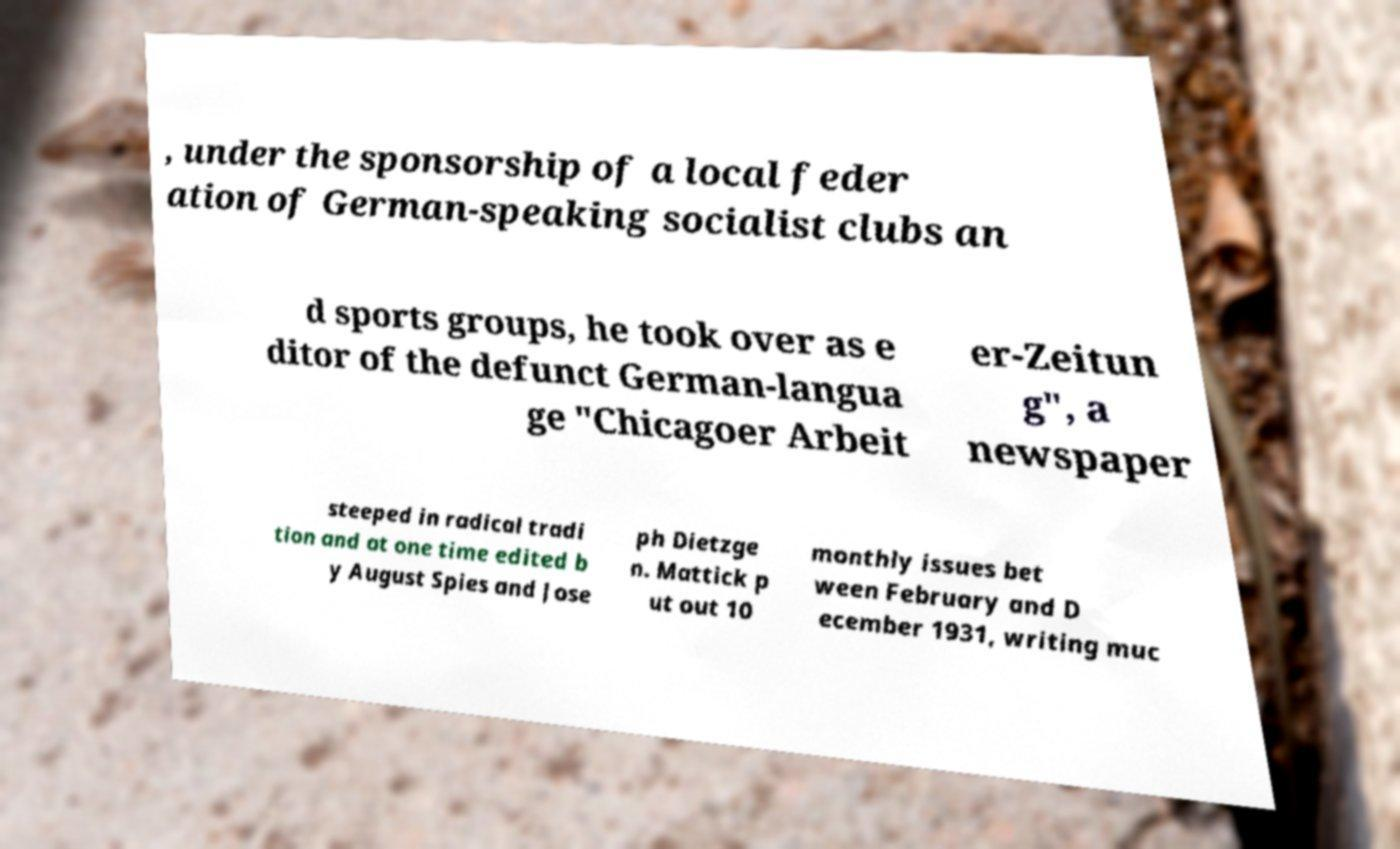Please identify and transcribe the text found in this image. , under the sponsorship of a local feder ation of German-speaking socialist clubs an d sports groups, he took over as e ditor of the defunct German-langua ge "Chicagoer Arbeit er-Zeitun g", a newspaper steeped in radical tradi tion and at one time edited b y August Spies and Jose ph Dietzge n. Mattick p ut out 10 monthly issues bet ween February and D ecember 1931, writing muc 